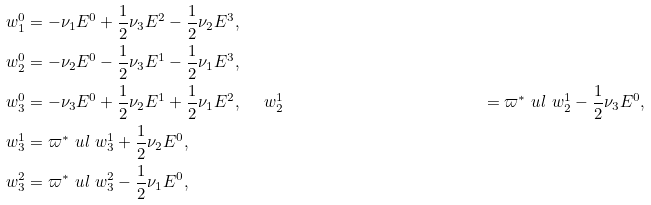<formula> <loc_0><loc_0><loc_500><loc_500>\ w ^ { 0 } _ { 1 } & = - \nu _ { 1 } E ^ { 0 } + \frac { 1 } { 2 } \nu _ { 3 } E ^ { 2 } - \frac { 1 } { 2 } \nu _ { 2 } E ^ { 3 } , \\ \ w ^ { 0 } _ { 2 } & = - \nu _ { 2 } E ^ { 0 } - \frac { 1 } { 2 } \nu _ { 3 } E ^ { 1 } - \frac { 1 } { 2 } \nu _ { 1 } E ^ { 3 } , \\ \ w ^ { 0 } _ { 3 } & = - \nu _ { 3 } E ^ { 0 } + \frac { 1 } { 2 } \nu _ { 2 } E ^ { 1 } + \frac { 1 } { 2 } \nu _ { 1 } E ^ { 2 } , \quad \ w ^ { 1 } _ { 2 } & = \varpi ^ { * } \ u l { \ w } ^ { 1 } _ { 2 } - \frac { 1 } { 2 } \nu _ { 3 } E ^ { 0 } , \\ \ w ^ { 1 } _ { 3 } & = \varpi ^ { * } \ u l { \ w } ^ { 1 } _ { 3 } + \frac { 1 } { 2 } \nu _ { 2 } E ^ { 0 } , \\ \ w ^ { 2 } _ { 3 } & = \varpi ^ { * } \ u l { \ w } ^ { 2 } _ { 3 } - \frac { 1 } { 2 } \nu _ { 1 } E ^ { 0 } ,</formula> 